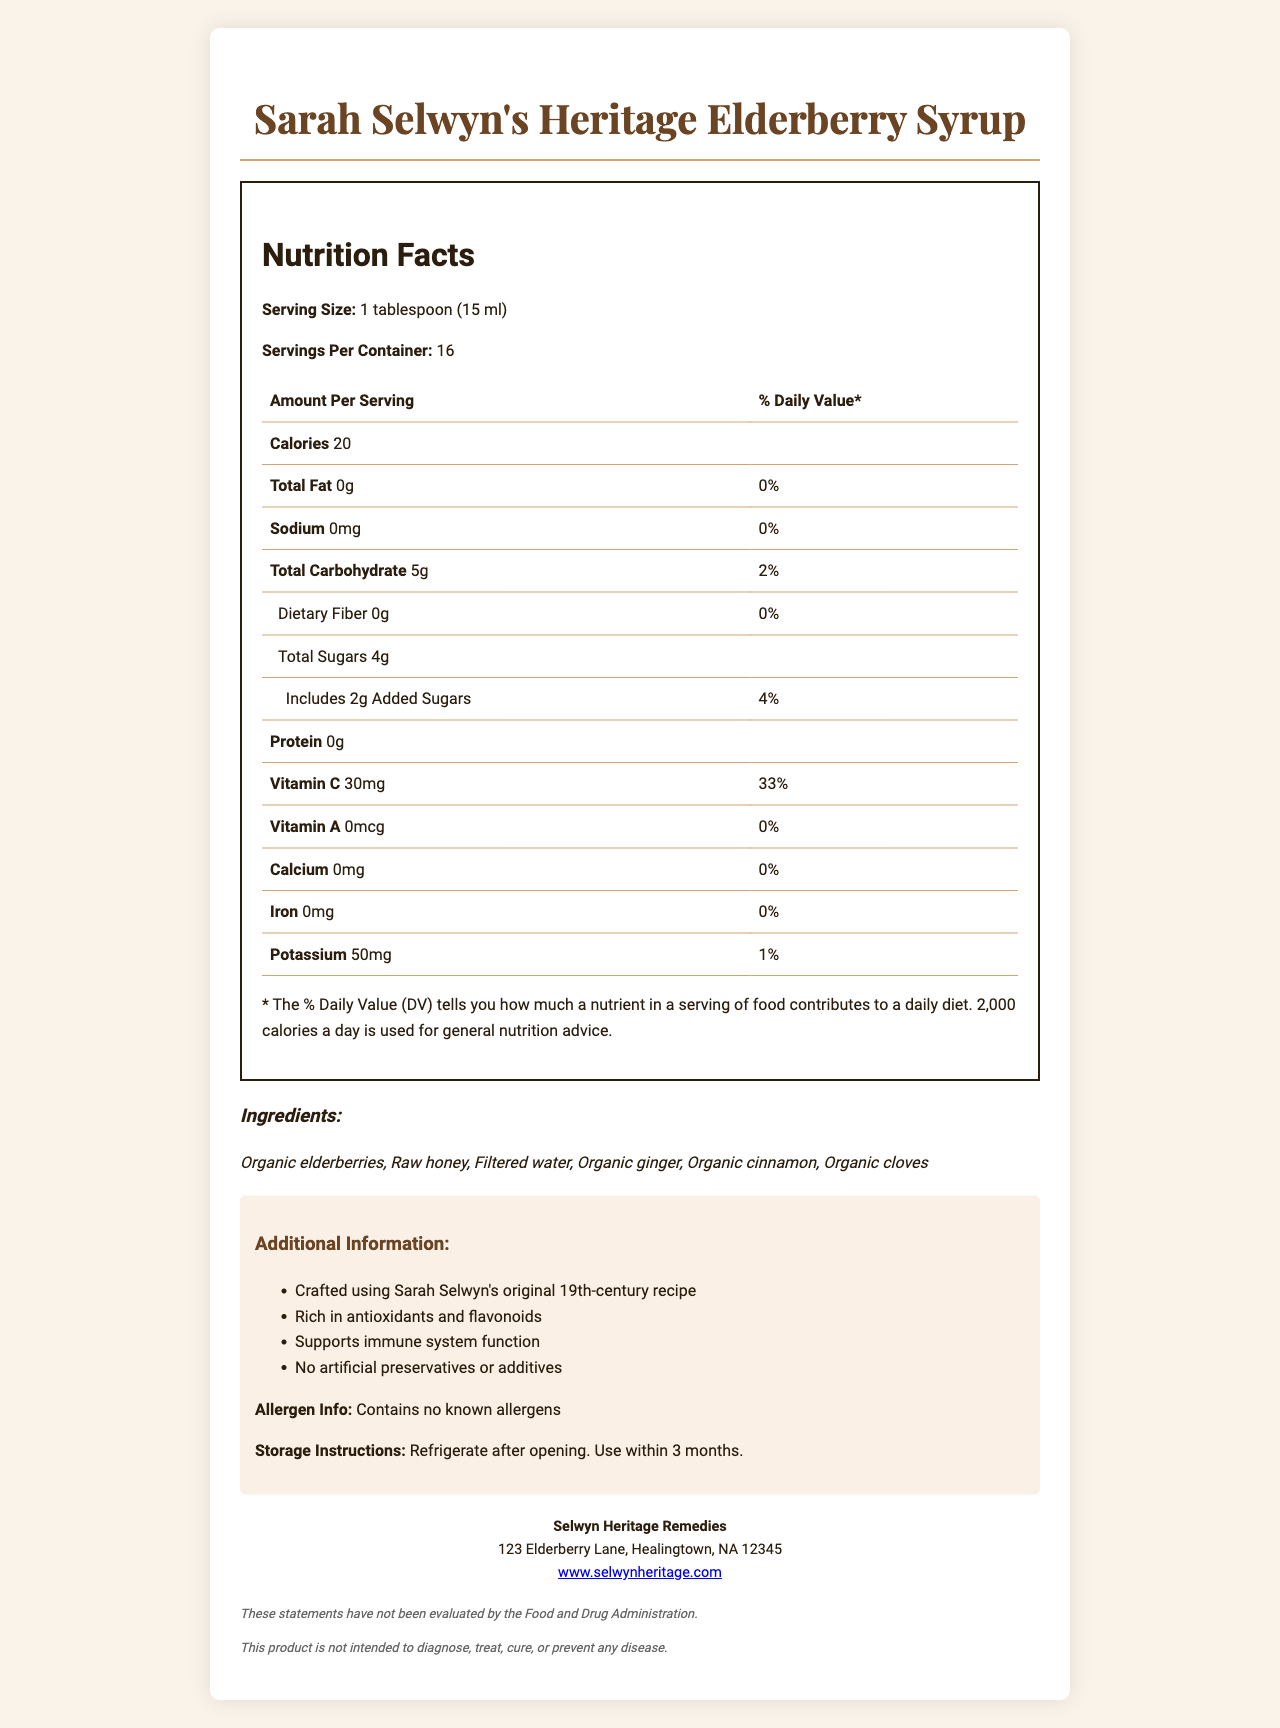what is the serving size? The serving size is indicated directly under the Nutrition Facts heading.
Answer: 1 tablespoon (15 ml) how many calories are in one serving of Sarah Selwyn's Heritage Elderberry Syrup? The number of calories per serving is listed under the "Amount Per Serving" section.
Answer: 20 calories what is the daily value percentage of vitamin C per serving? The daily value percentage for vitamin C can be found in the list of nutrients under "Vitamin C."
Answer: 33% what ingredients are used in the syrup? The list of ingredients is provided in the "Ingredients" section.
Answer: Organic elderberries, Raw honey, Filtered water, Organic ginger, Organic cinnamon, Organic cloves how many grams of added sugars are in each serving? The amount of added sugars per serving is listed in the "Total Sugars" breakdown.
Answer: 2g how should the syrup be stored after opening? The storage instructions are provided in the "Additional Information" section.
Answer: Refrigerate after opening. Use within 3 months. which of the following nutrients is NOT present in significant amounts in the syrup? A. Iron B. Vitamin C C. Calcium D. Protein Iron is listed with a daily value percentage of 0%, indicating it's not present in significant amounts.
Answer: A. Iron who is the manufacturer of the syrup? A. Heritage Healers B. Sarah's Remedies C. Selwyn Heritage Remedies D. Elderberry Elixirs The manufacturer's name is provided under the "Manufacturer Info" section.
Answer: C. Selwyn Heritage Remedies is there any information about allergens in this syrup? The allergen information is stated to contain no known allergens in the "Additional Information" section.
Answer: Yes does this product contain any artificial preservatives or additives? The document states that it contains no artificial preservatives or additives in the "Additional Information" section.
Answer: No summarize the document. The summary captures the key features of the document, highlighting its nutritional content, ingredients, and additional important information.
Answer: The document provides the nutrition facts, ingredients, additional information, and manufacturing details for Sarah Selwyn's Heritage Elderberry Syrup. Emphasis is placed on its high vitamin C content and immune-boosting properties. Storage instructions and disclaimers are also included. what is the vitamin A content in one serving? The amount of vitamin A is shown as 0mcg in the list of nutrients.
Answer: 0mcg how many servings are in each container? The number of servings per container is listed near the top of the nutrition label.
Answer: 16 can this syrup be used to treat diseases according to the document? The disclaimer clearly states that the product is not intended to diagnose, treat, cure, or prevent any disease.
Answer: No how did Sarah Selwyn contribute to this product? There is not enough information provided in the document to understand Sarah Selwyn's specific contributions. It only mentions that the syrup is crafted using her original 19th-century recipe.
Answer: Cannot be determined 